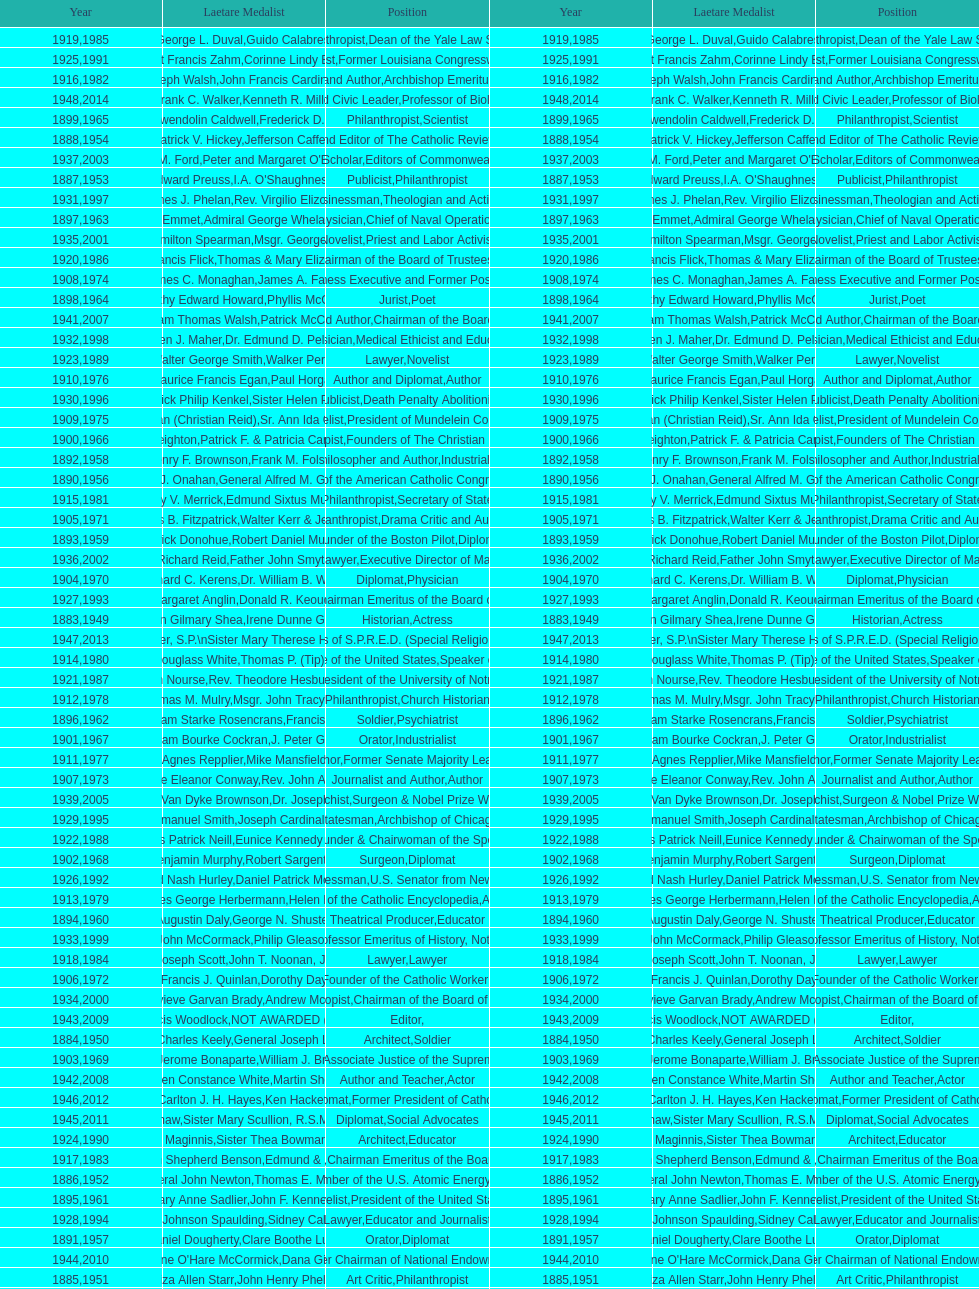How many times does philanthropist appear in the position column on this chart? 9. 